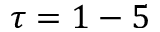<formula> <loc_0><loc_0><loc_500><loc_500>\tau = 1 - 5</formula> 